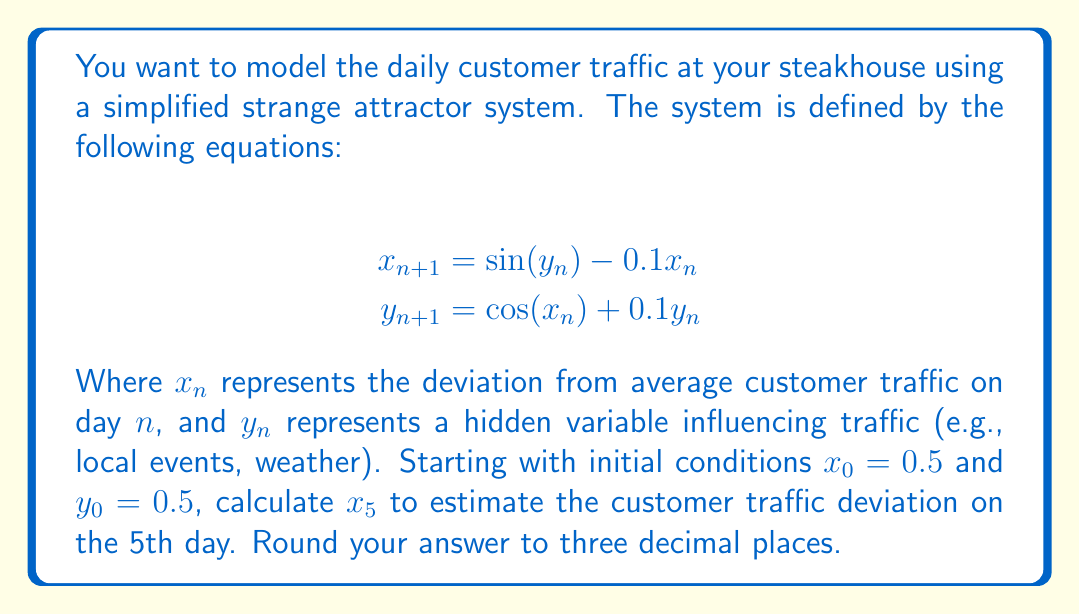Can you answer this question? To solve this problem, we need to iterate the system equations for 5 steps:

Step 1: Calculate $x_1$ and $y_1$
$$\begin{align}
x_1 &= \sin(0.5) - 0.1(0.5) = 0.4794 - 0.05 = 0.4294 \\
y_1 &= \cos(0.5) + 0.1(0.5) = 0.8776 + 0.05 = 0.9276
\end{align}$$

Step 2: Calculate $x_2$ and $y_2$
$$\begin{align}
x_2 &= \sin(0.9276) - 0.1(0.4294) = 0.7988 - 0.0429 = 0.7559 \\
y_2 &= \cos(0.4294) + 0.1(0.9276) = 0.9080 + 0.0928 = 1.0008
\end{align}$$

Step 3: Calculate $x_3$ and $y_3$
$$\begin{align}
x_3 &= \sin(1.0008) - 0.1(0.7559) = 0.8422 - 0.0756 = 0.7666 \\
y_3 &= \cos(0.7559) + 0.1(1.0008) = 0.7267 + 0.1001 = 0.8268
\end{align}$$

Step 4: Calculate $x_4$ and $y_4$
$$\begin{align}
x_4 &= \sin(0.8268) - 0.1(0.7666) = 0.7376 - 0.0767 = 0.6609 \\
y_4 &= \cos(0.7666) + 0.1(0.8268) = 0.7192 + 0.0827 = 0.8019
\end{align}$$

Step 5: Calculate $x_5$ (final result)
$$\begin{align}
x_5 &= \sin(0.8019) - 0.1(0.6609) = 0.7174 - 0.0661 = 0.6513
\end{align}$$

Rounding to three decimal places, we get $x_5 = 0.651$.
Answer: 0.651 